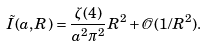<formula> <loc_0><loc_0><loc_500><loc_500>\tilde { I } ( a , R ) = \frac { \zeta ( 4 ) } { a ^ { 2 } \pi ^ { 2 } } R ^ { 2 } + \mathcal { O } ( 1 / R ^ { 2 } ) .</formula> 